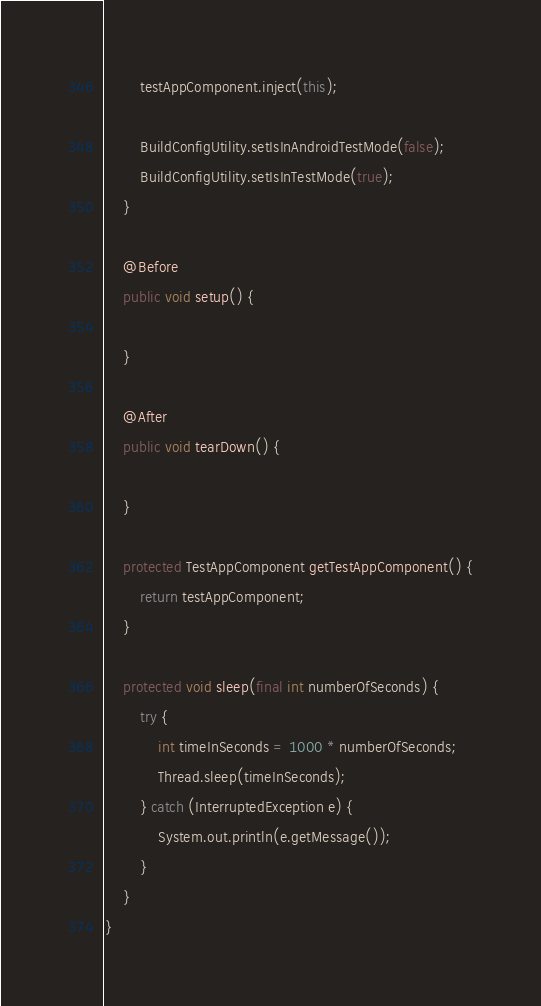Convert code to text. <code><loc_0><loc_0><loc_500><loc_500><_Java_>        testAppComponent.inject(this);

        BuildConfigUtility.setIsInAndroidTestMode(false);
        BuildConfigUtility.setIsInTestMode(true);
    }

    @Before
    public void setup() {

    }

    @After
    public void tearDown() {

    }

    protected TestAppComponent getTestAppComponent() {
        return testAppComponent;
    }

    protected void sleep(final int numberOfSeconds) {
        try {
            int timeInSeconds = 1000 * numberOfSeconds;
            Thread.sleep(timeInSeconds);
        } catch (InterruptedException e) {
            System.out.println(e.getMessage());
        }
    }
}
</code> 